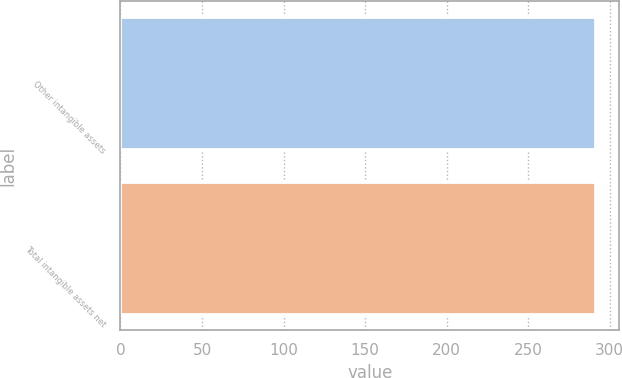<chart> <loc_0><loc_0><loc_500><loc_500><bar_chart><fcel>Other intangible assets<fcel>Total intangible assets net<nl><fcel>291<fcel>291.1<nl></chart> 